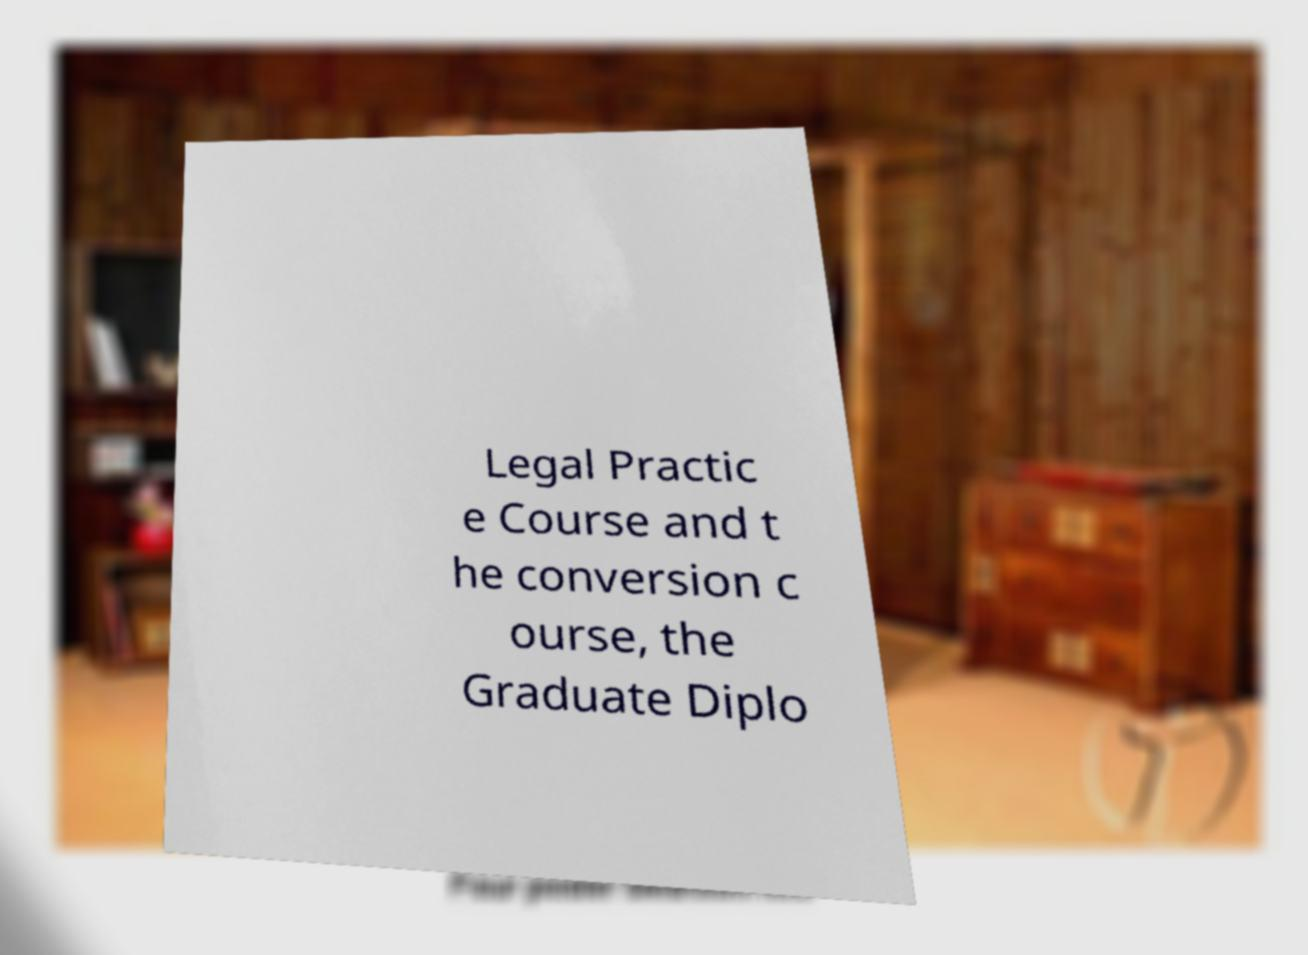There's text embedded in this image that I need extracted. Can you transcribe it verbatim? Legal Practic e Course and t he conversion c ourse, the Graduate Diplo 